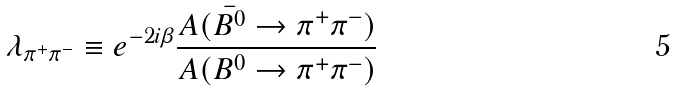Convert formula to latex. <formula><loc_0><loc_0><loc_500><loc_500>\lambda _ { \pi ^ { + } \pi ^ { - } } \equiv e ^ { - 2 i \beta } \frac { A ( \bar { B ^ { 0 } } \to \pi ^ { + } \pi ^ { - } ) } { A ( B ^ { 0 } \to \pi ^ { + } \pi ^ { - } ) }</formula> 